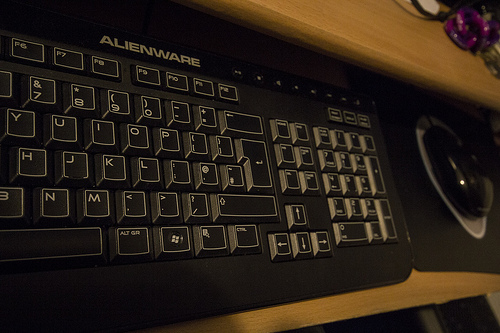What brand is the keyboard shown in the image? The keyboard in the picture has the branding of 'Alienware,' which is known for its gaming-oriented computer hardware. 